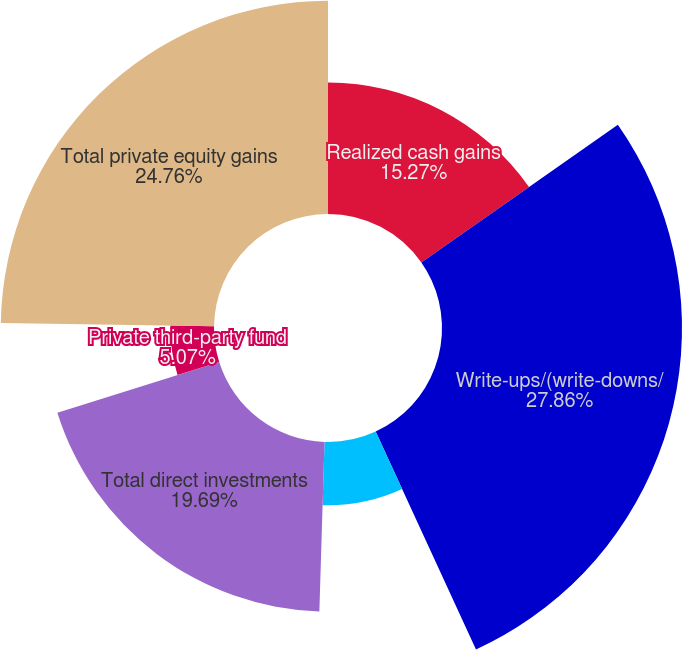Convert chart. <chart><loc_0><loc_0><loc_500><loc_500><pie_chart><fcel>Realized cash gains<fcel>Write-ups/(write-downs/<fcel>MTM gains (losses) (a)<fcel>Total direct investments<fcel>Private third-party fund<fcel>Total private equity gains<nl><fcel>15.27%<fcel>27.87%<fcel>7.35%<fcel>19.69%<fcel>5.07%<fcel>24.76%<nl></chart> 